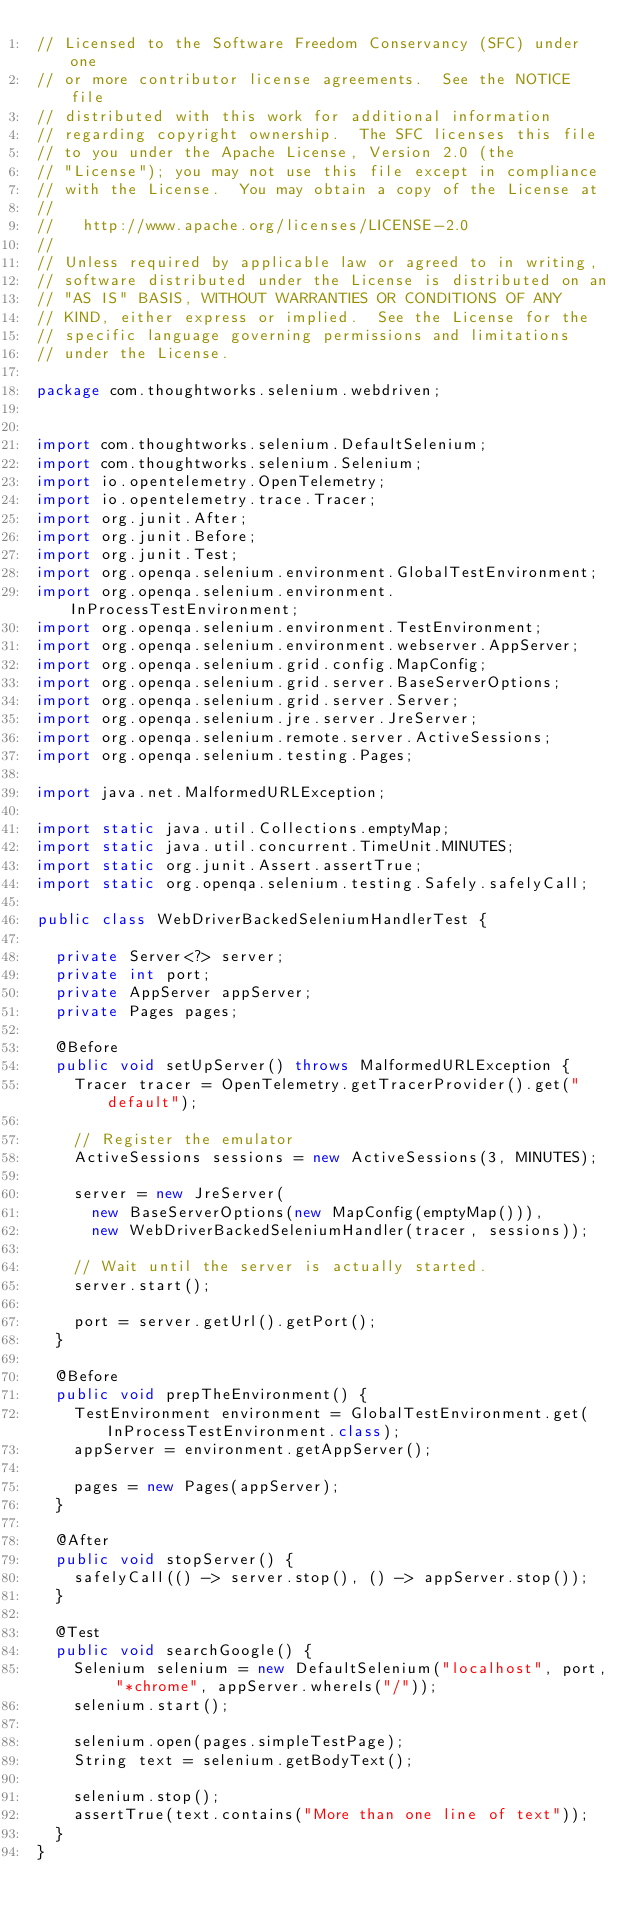Convert code to text. <code><loc_0><loc_0><loc_500><loc_500><_Java_>// Licensed to the Software Freedom Conservancy (SFC) under one
// or more contributor license agreements.  See the NOTICE file
// distributed with this work for additional information
// regarding copyright ownership.  The SFC licenses this file
// to you under the Apache License, Version 2.0 (the
// "License"); you may not use this file except in compliance
// with the License.  You may obtain a copy of the License at
//
//   http://www.apache.org/licenses/LICENSE-2.0
//
// Unless required by applicable law or agreed to in writing,
// software distributed under the License is distributed on an
// "AS IS" BASIS, WITHOUT WARRANTIES OR CONDITIONS OF ANY
// KIND, either express or implied.  See the License for the
// specific language governing permissions and limitations
// under the License.

package com.thoughtworks.selenium.webdriven;


import com.thoughtworks.selenium.DefaultSelenium;
import com.thoughtworks.selenium.Selenium;
import io.opentelemetry.OpenTelemetry;
import io.opentelemetry.trace.Tracer;
import org.junit.After;
import org.junit.Before;
import org.junit.Test;
import org.openqa.selenium.environment.GlobalTestEnvironment;
import org.openqa.selenium.environment.InProcessTestEnvironment;
import org.openqa.selenium.environment.TestEnvironment;
import org.openqa.selenium.environment.webserver.AppServer;
import org.openqa.selenium.grid.config.MapConfig;
import org.openqa.selenium.grid.server.BaseServerOptions;
import org.openqa.selenium.grid.server.Server;
import org.openqa.selenium.jre.server.JreServer;
import org.openqa.selenium.remote.server.ActiveSessions;
import org.openqa.selenium.testing.Pages;

import java.net.MalformedURLException;

import static java.util.Collections.emptyMap;
import static java.util.concurrent.TimeUnit.MINUTES;
import static org.junit.Assert.assertTrue;
import static org.openqa.selenium.testing.Safely.safelyCall;

public class WebDriverBackedSeleniumHandlerTest {

  private Server<?> server;
  private int port;
  private AppServer appServer;
  private Pages pages;

  @Before
  public void setUpServer() throws MalformedURLException {
    Tracer tracer = OpenTelemetry.getTracerProvider().get("default");

    // Register the emulator
    ActiveSessions sessions = new ActiveSessions(3, MINUTES);

    server = new JreServer(
      new BaseServerOptions(new MapConfig(emptyMap())),
      new WebDriverBackedSeleniumHandler(tracer, sessions));

    // Wait until the server is actually started.
    server.start();

    port = server.getUrl().getPort();
  }

  @Before
  public void prepTheEnvironment() {
    TestEnvironment environment = GlobalTestEnvironment.get(InProcessTestEnvironment.class);
    appServer = environment.getAppServer();

    pages = new Pages(appServer);
  }

  @After
  public void stopServer() {
    safelyCall(() -> server.stop(), () -> appServer.stop());
  }

  @Test
  public void searchGoogle() {
    Selenium selenium = new DefaultSelenium("localhost", port, "*chrome", appServer.whereIs("/"));
    selenium.start();

    selenium.open(pages.simpleTestPage);
    String text = selenium.getBodyText();

    selenium.stop();
    assertTrue(text.contains("More than one line of text"));
  }
}
</code> 